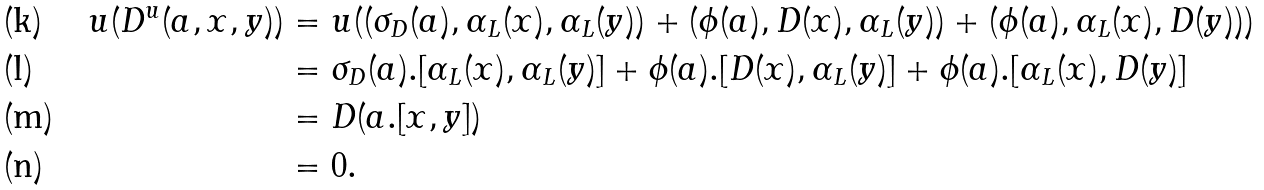Convert formula to latex. <formula><loc_0><loc_0><loc_500><loc_500>u ( D ^ { u } ( a , x , y ) ) & = u ( ( \sigma _ { D } ( a ) , \alpha _ { L } ( x ) , \alpha _ { L } ( y ) ) + ( \phi ( a ) , D ( x ) , \alpha _ { L } ( y ) ) + ( \phi ( a ) , \alpha _ { L } ( x ) , D ( y ) ) ) \\ & = \sigma _ { D } ( a ) . [ \alpha _ { L } ( x ) , \alpha _ { L } ( y ) ] + \phi ( a ) . [ D ( x ) , \alpha _ { L } ( y ) ] + \phi ( a ) . [ \alpha _ { L } ( x ) , D ( y ) ] \\ & = D ( a . [ x , y ] ) \\ & = 0 .</formula> 